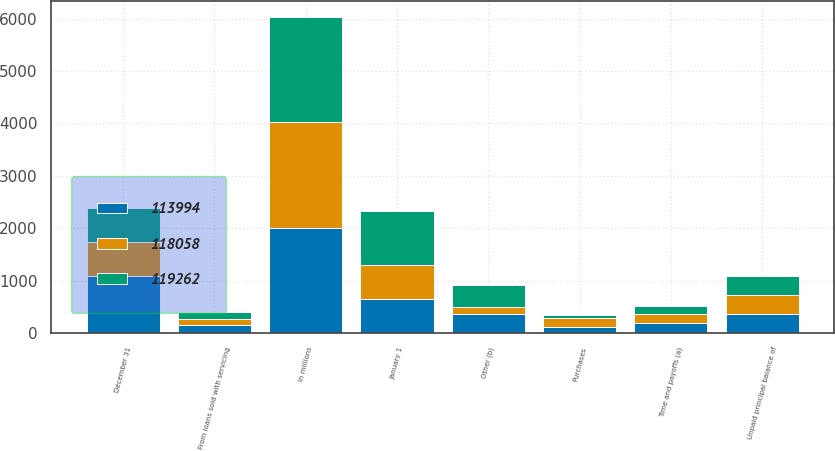Convert chart. <chart><loc_0><loc_0><loc_500><loc_500><stacked_bar_chart><ecel><fcel>In millions<fcel>January 1<fcel>From loans sold with servicing<fcel>Purchases<fcel>Time and payoffs (a)<fcel>Other (b)<fcel>December 31<fcel>Unpaid principal balance of<nl><fcel>113994<fcel>2013<fcel>650<fcel>158<fcel>110<fcel>193<fcel>366<fcel>1087<fcel>366<nl><fcel>118058<fcel>2012<fcel>647<fcel>117<fcel>175<fcel>167<fcel>138<fcel>650<fcel>366<nl><fcel>119262<fcel>2011<fcel>1033<fcel>118<fcel>65<fcel>163<fcel>406<fcel>647<fcel>366<nl></chart> 